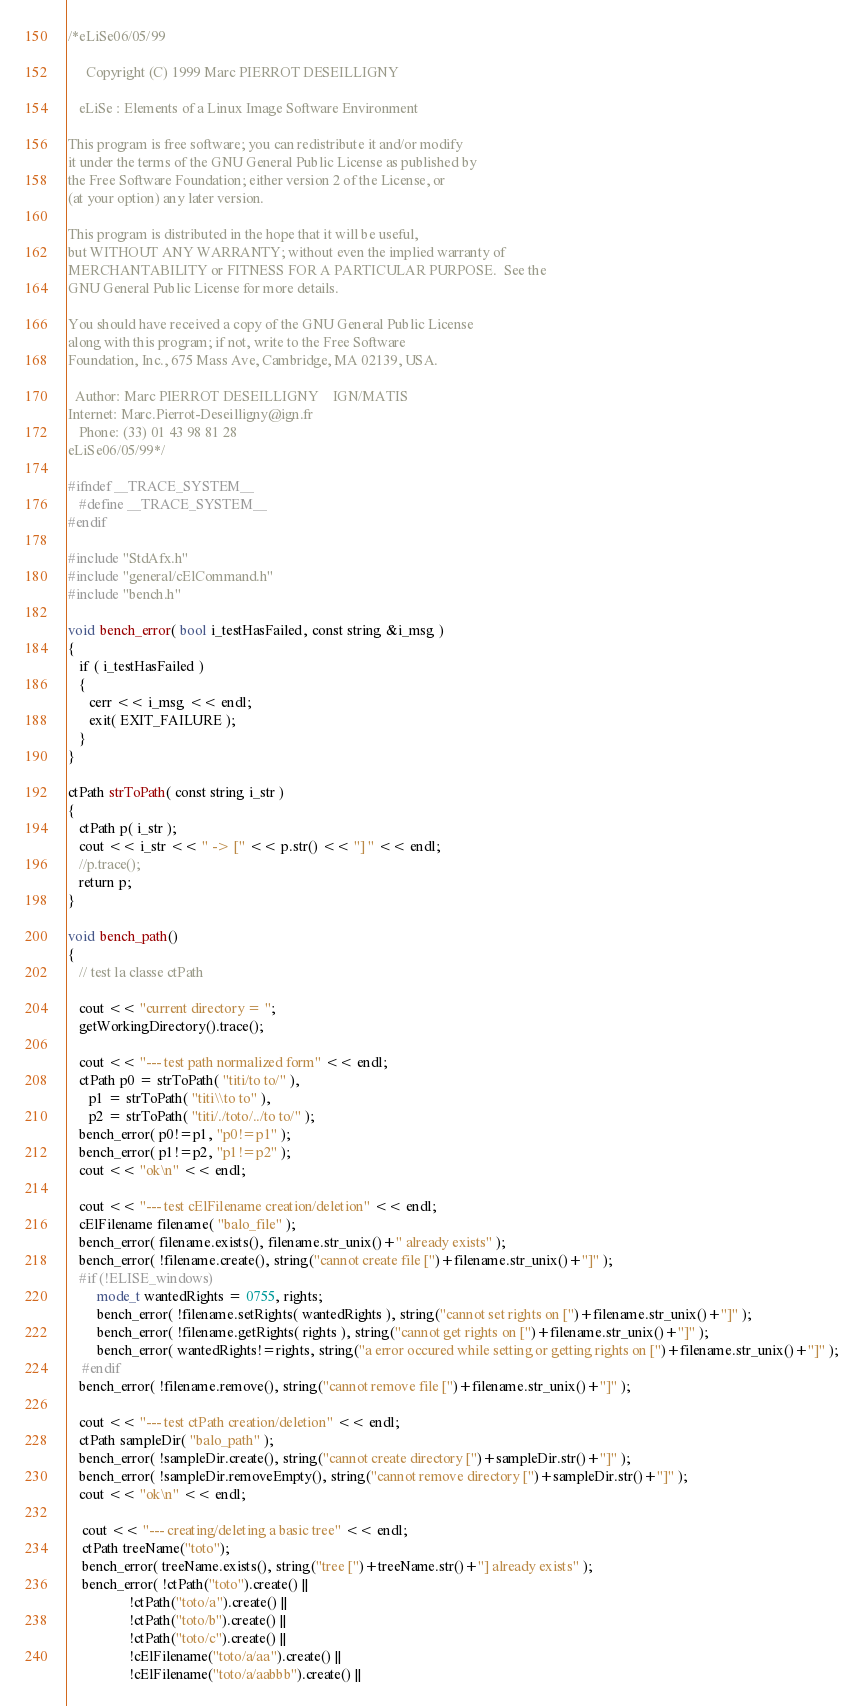Convert code to text. <code><loc_0><loc_0><loc_500><loc_500><_C++_>/*eLiSe06/05/99
  
     Copyright (C) 1999 Marc PIERROT DESEILLIGNY

   eLiSe : Elements of a Linux Image Software Environment

This program is free software; you can redistribute it and/or modify
it under the terms of the GNU General Public License as published by
the Free Software Foundation; either version 2 of the License, or
(at your option) any later version.

This program is distributed in the hope that it will be useful,
but WITHOUT ANY WARRANTY; without even the implied warranty of
MERCHANTABILITY or FITNESS FOR A PARTICULAR PURPOSE.  See the
GNU General Public License for more details.

You should have received a copy of the GNU General Public License
along with this program; if not, write to the Free Software
Foundation, Inc., 675 Mass Ave, Cambridge, MA 02139, USA.

  Author: Marc PIERROT DESEILLIGNY    IGN/MATIS  
Internet: Marc.Pierrot-Deseilligny@ign.fr
   Phone: (33) 01 43 98 81 28
eLiSe06/05/99*/

#ifndef __TRACE_SYSTEM__
   #define __TRACE_SYSTEM__
#endif

#include "StdAfx.h"
#include "general/cElCommand.h"
#include "bench.h"

void bench_error( bool i_testHasFailed, const string &i_msg )
{
   if ( i_testHasFailed )
   {
      cerr << i_msg << endl;
      exit( EXIT_FAILURE );
   }
}

ctPath strToPath( const string i_str )
{
   ctPath p( i_str );
   cout << i_str << " -> [" << p.str() << "] " << endl;
   //p.trace();
   return p;
}

void bench_path()
{
   // test la classe ctPath

   cout << "current directory = ";
   getWorkingDirectory().trace();

   cout << "--- test path normalized form" << endl;
   ctPath p0 = strToPath( "titi/to to/" ),
	  p1 = strToPath( "titi\\to to" ),
	  p2 = strToPath( "titi/./toto/../to to/" );
   bench_error( p0!=p1, "p0!=p1" );
   bench_error( p1!=p2, "p1!=p2" );
   cout << "ok\n" << endl;

   cout << "--- test cElFilename creation/deletion" << endl;
   cElFilename filename( "balo_file" );
   bench_error( filename.exists(), filename.str_unix()+" already exists" );
   bench_error( !filename.create(), string("cannot create file [")+filename.str_unix()+"]" );
   #if (!ELISE_windows)
		mode_t wantedRights = 0755, rights;
		bench_error( !filename.setRights( wantedRights ), string("cannot set rights on [")+filename.str_unix()+"]" );
		bench_error( !filename.getRights( rights ), string("cannot get rights on [")+filename.str_unix()+"]" );
		bench_error( wantedRights!=rights, string("a error occured while setting or getting rights on [")+filename.str_unix()+"]" );
	#endif
   bench_error( !filename.remove(), string("cannot remove file [")+filename.str_unix()+"]" );
   
   cout << "--- test ctPath creation/deletion" << endl;
   ctPath sampleDir( "balo_path" );
   bench_error( !sampleDir.create(), string("cannot create directory [")+sampleDir.str()+"]" );
   bench_error( !sampleDir.removeEmpty(), string("cannot remove directory [")+sampleDir.str()+"]" );
   cout << "ok\n" << endl;
   
	cout << "--- creating/deleting a basic tree" << endl;
	ctPath treeName("toto");
	bench_error( treeName.exists(), string("tree [")+treeName.str()+"] already exists" );
	bench_error( !ctPath("toto").create() ||
	             !ctPath("toto/a").create() ||
	             !ctPath("toto/b").create() ||
	             !ctPath("toto/c").create() ||
	             !cElFilename("toto/a/aa").create() ||
	             !cElFilename("toto/a/aabbb").create() ||</code> 